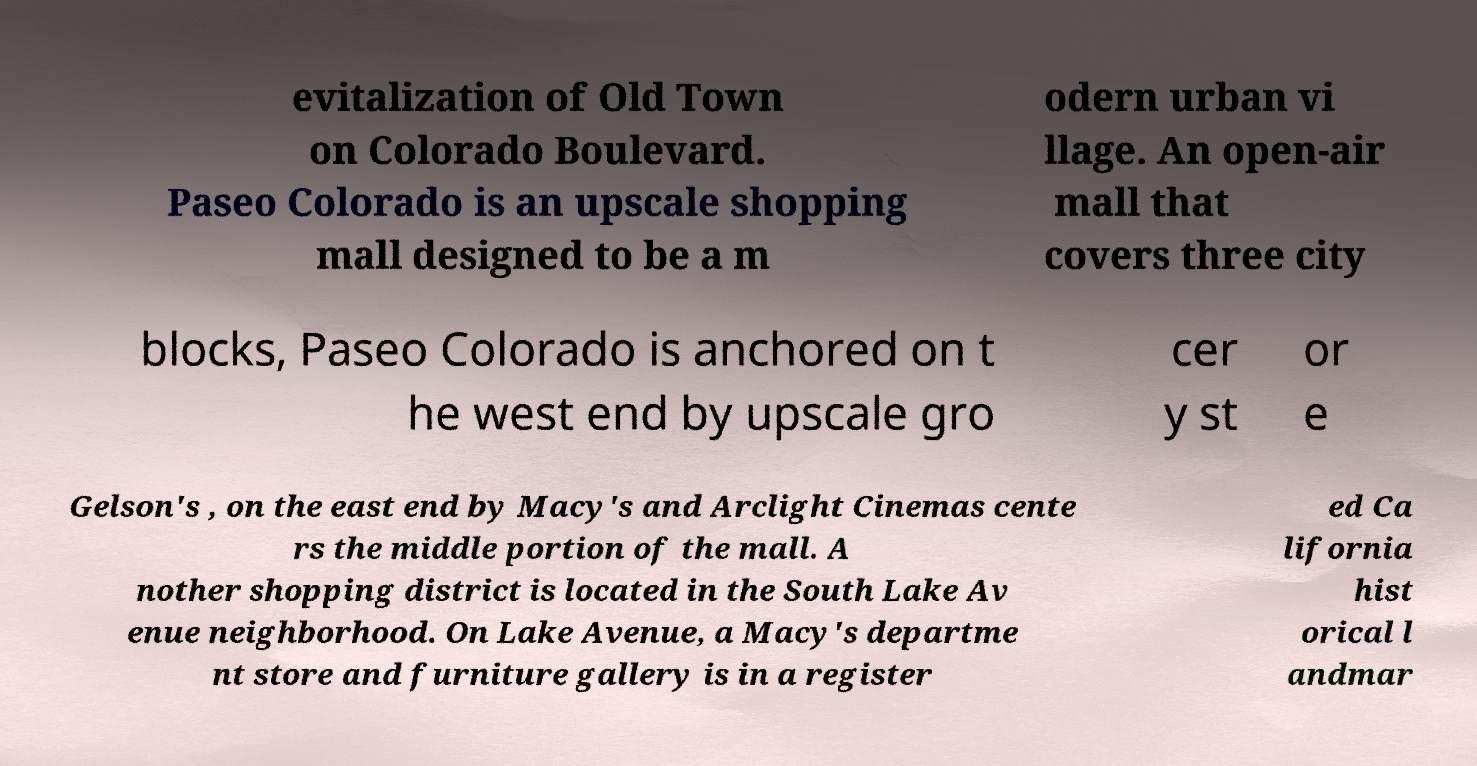For documentation purposes, I need the text within this image transcribed. Could you provide that? evitalization of Old Town on Colorado Boulevard. Paseo Colorado is an upscale shopping mall designed to be a m odern urban vi llage. An open-air mall that covers three city blocks, Paseo Colorado is anchored on t he west end by upscale gro cer y st or e Gelson's , on the east end by Macy's and Arclight Cinemas cente rs the middle portion of the mall. A nother shopping district is located in the South Lake Av enue neighborhood. On Lake Avenue, a Macy's departme nt store and furniture gallery is in a register ed Ca lifornia hist orical l andmar 